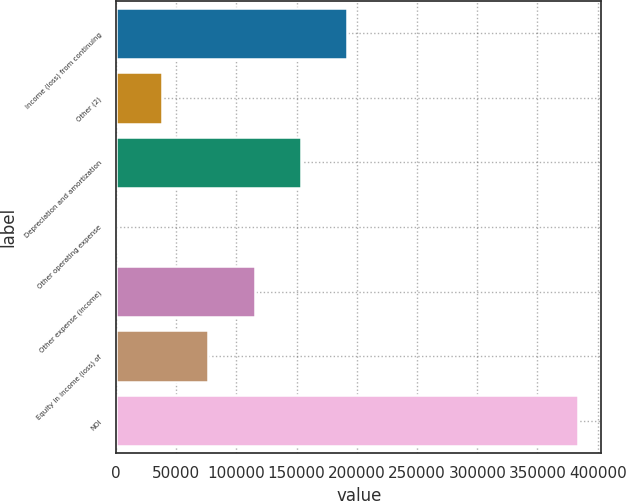Convert chart. <chart><loc_0><loc_0><loc_500><loc_500><bar_chart><fcel>Income (loss) from continuing<fcel>Other (2)<fcel>Depreciation and amortization<fcel>Other operating expense<fcel>Other expense (income)<fcel>Equity in income (loss) of<fcel>NOI<nl><fcel>191944<fcel>38396<fcel>153557<fcel>9<fcel>115170<fcel>76783<fcel>383879<nl></chart> 